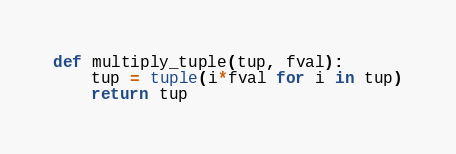Convert code to text. <code><loc_0><loc_0><loc_500><loc_500><_Python_>
def multiply_tuple(tup, fval):
    tup = tuple(i*fval for i in tup)
    return tup</code> 